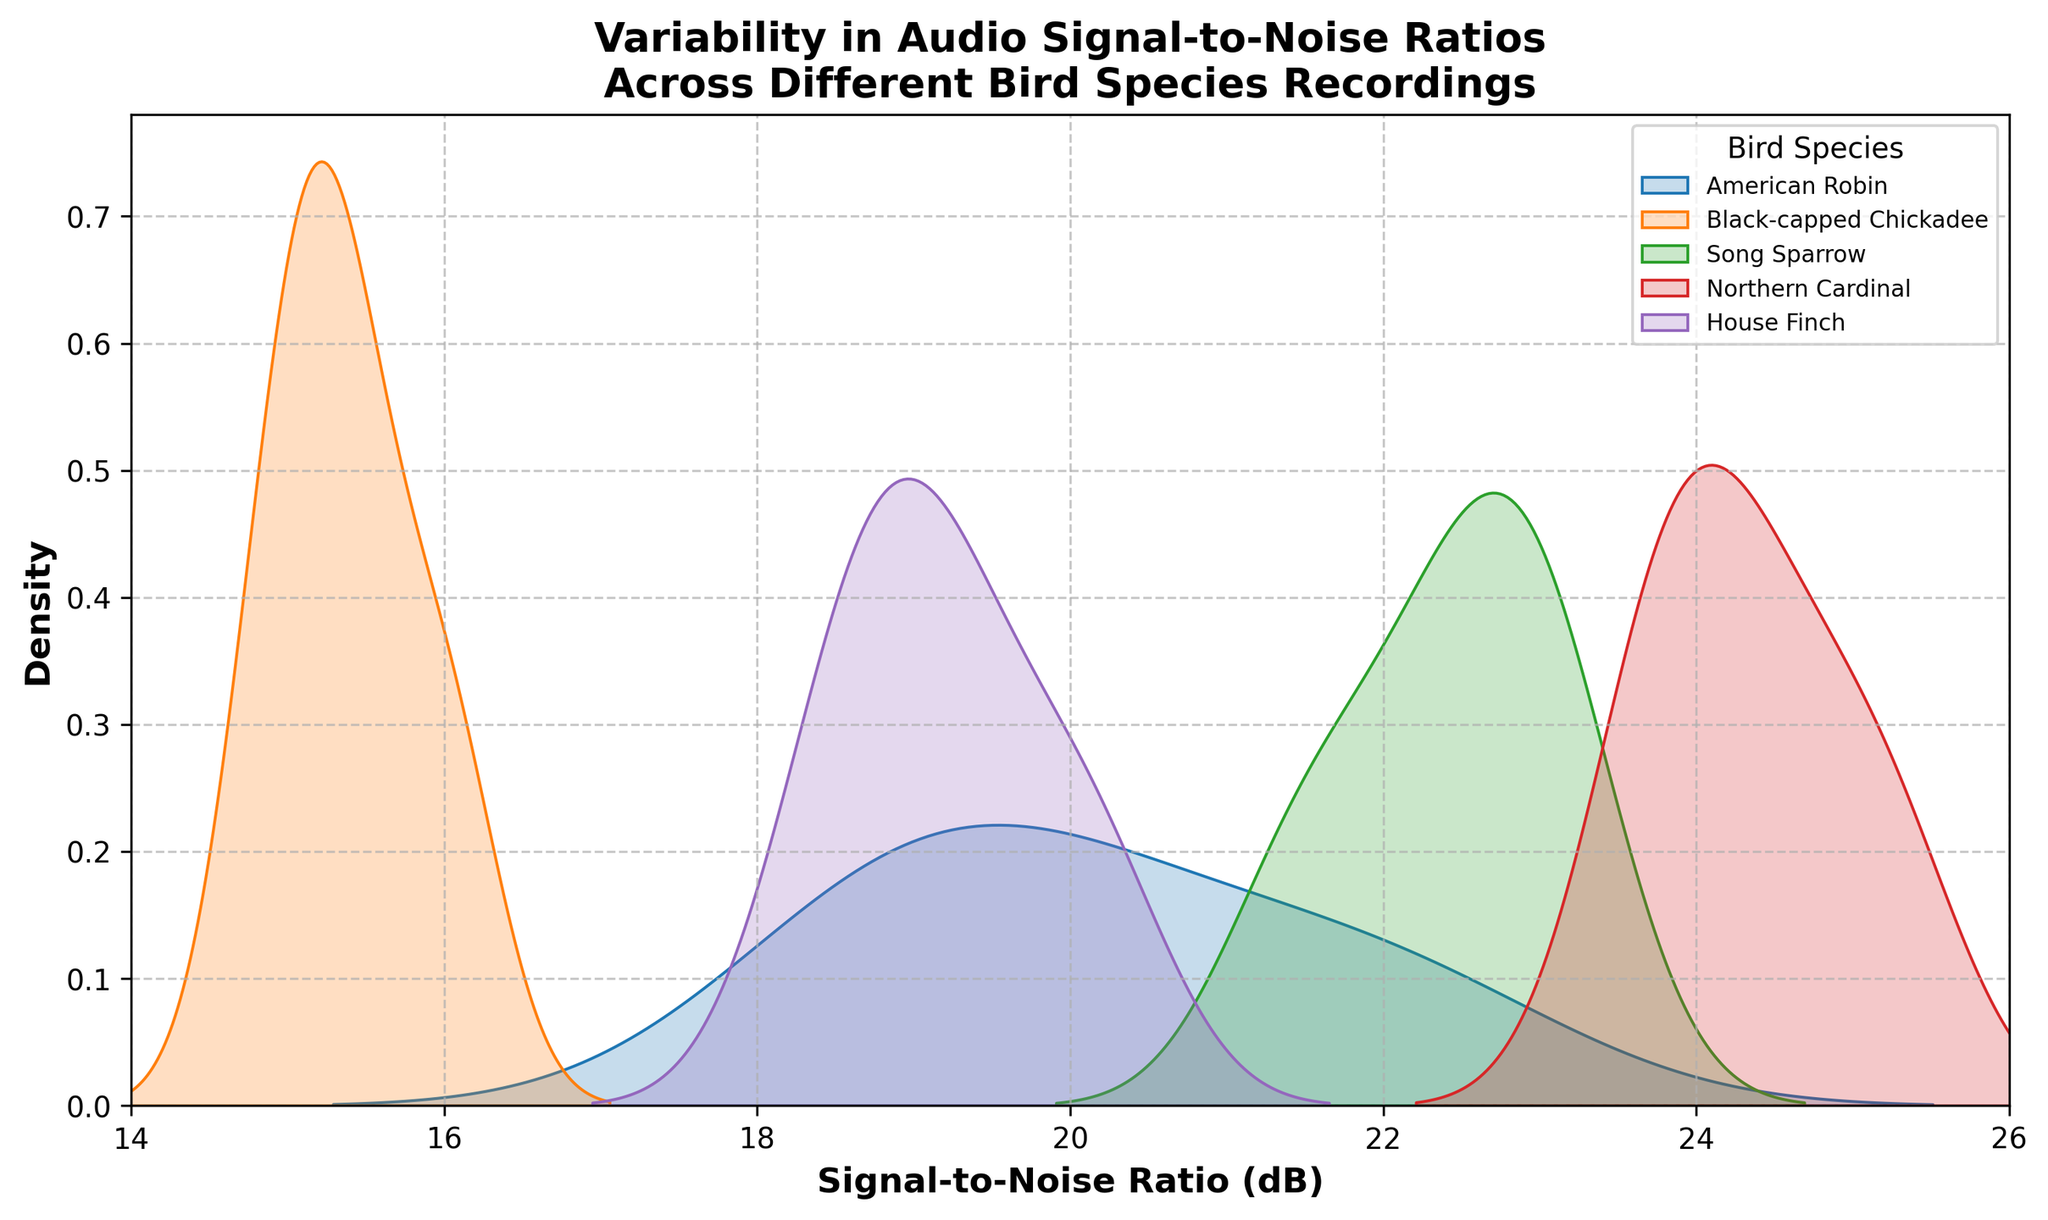What is the title of the figure? The title of the figure is usually displayed at the top center. In this case, it reads 'Variability in Audio Signal-to-Noise Ratios Across Different Bird Species Recordings'.
Answer: Variability in Audio Signal-to-Noise Ratios Across Different Bird Species Recordings Which bird species has the highest peak density in its distribution? To find the bird species with the highest peak density, look for the species plot with the tallest peak on the density plot. In this case, the Northern Cardinal's density plot reaches the highest peak.
Answer: Northern Cardinal What is the x-axis labeled? The x-axis label is usually located below the axis and indicates the variable being measured. Here, it is labeled 'Signal-to-Noise Ratio (dB)'.
Answer: Signal-to-Noise Ratio (dB) What Signal-to-Noise Ratio range is covered on the x-axis? The x-axis range can be determined by looking at the tick marks on the horizontal axis. In this plot, the x-axis ranges from 14 to 26 dB.
Answer: 14 to 26 Which two bird species have overlapping peaks in their density distributions? To determine this, observe the density plot lines for overlaps. The American Robin and the Song Sparrow's density distributions both peak and overlap around the 19.5 to 22.5 dB range.
Answer: American Robin and Song Sparrow Which bird species shows the least variability in Signal-to-Noise Ratios? The species with the least variability will have the narrowest distribution. The Northern Cardinal has a sharp and narrow distribution, indicating the least variability.
Answer: Northern Cardinal How does the Signal-to-Noise Ratio distribution of the American Robin compare to that of the House Finch? Comparing the density plots, the American Robin's distribution is slightly broader and peaks lower compared to the House Finch.
Answer: The American Robin is broader and peaks lower Among the species shown, which one has the lowest Signal-to-Noise Ratio in its distribution? Look at the leftmost part of all the density distributions. The Black-capped Chickadee's distribution reaches down to around 14.9 dB, which is the lowest.
Answer: Black-capped Chickadee Which bird species distribution has a peak around 19 dB? By observing the density plots, we can see that the American Robin has a peak density around the 19 dB mark.
Answer: American Robin 